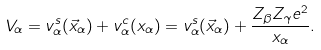<formula> <loc_0><loc_0><loc_500><loc_500>V _ { \alpha } = v ^ { s } _ { \alpha } ( \vec { x } _ { \alpha } ) + v ^ { c } _ { \alpha } ( x _ { \alpha } ) = v ^ { s } _ { \alpha } ( \vec { x } _ { \alpha } ) + \frac { Z _ { \beta } Z _ { \gamma } e ^ { 2 } } { x _ { \alpha } } .</formula> 